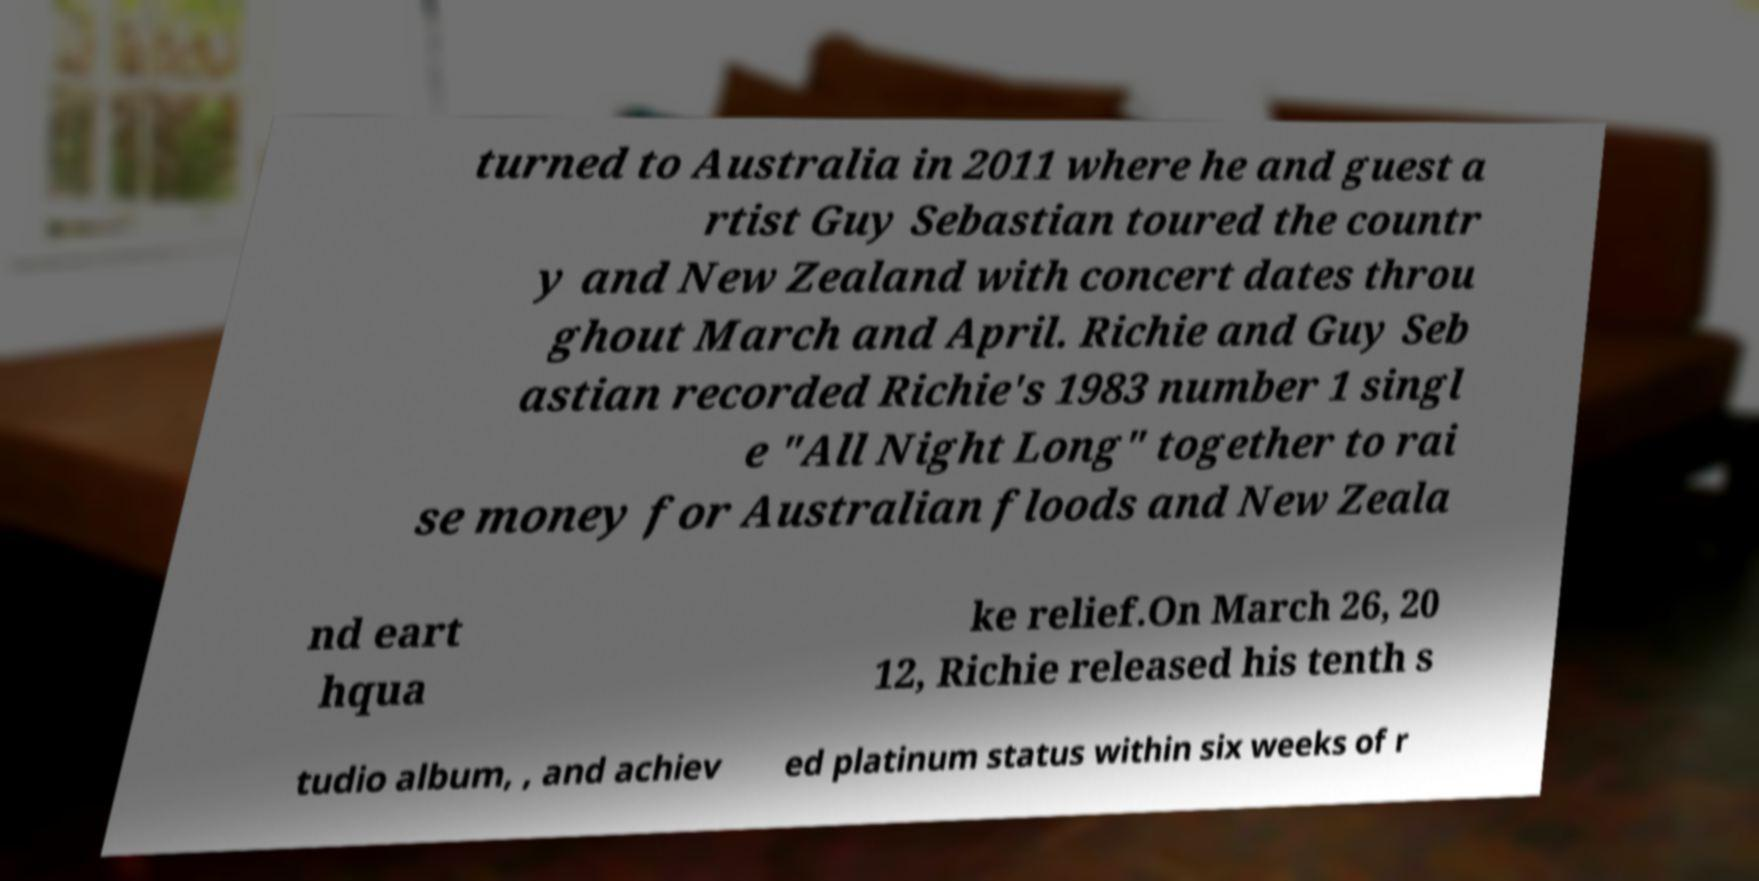What messages or text are displayed in this image? I need them in a readable, typed format. turned to Australia in 2011 where he and guest a rtist Guy Sebastian toured the countr y and New Zealand with concert dates throu ghout March and April. Richie and Guy Seb astian recorded Richie's 1983 number 1 singl e "All Night Long" together to rai se money for Australian floods and New Zeala nd eart hqua ke relief.On March 26, 20 12, Richie released his tenth s tudio album, , and achiev ed platinum status within six weeks of r 